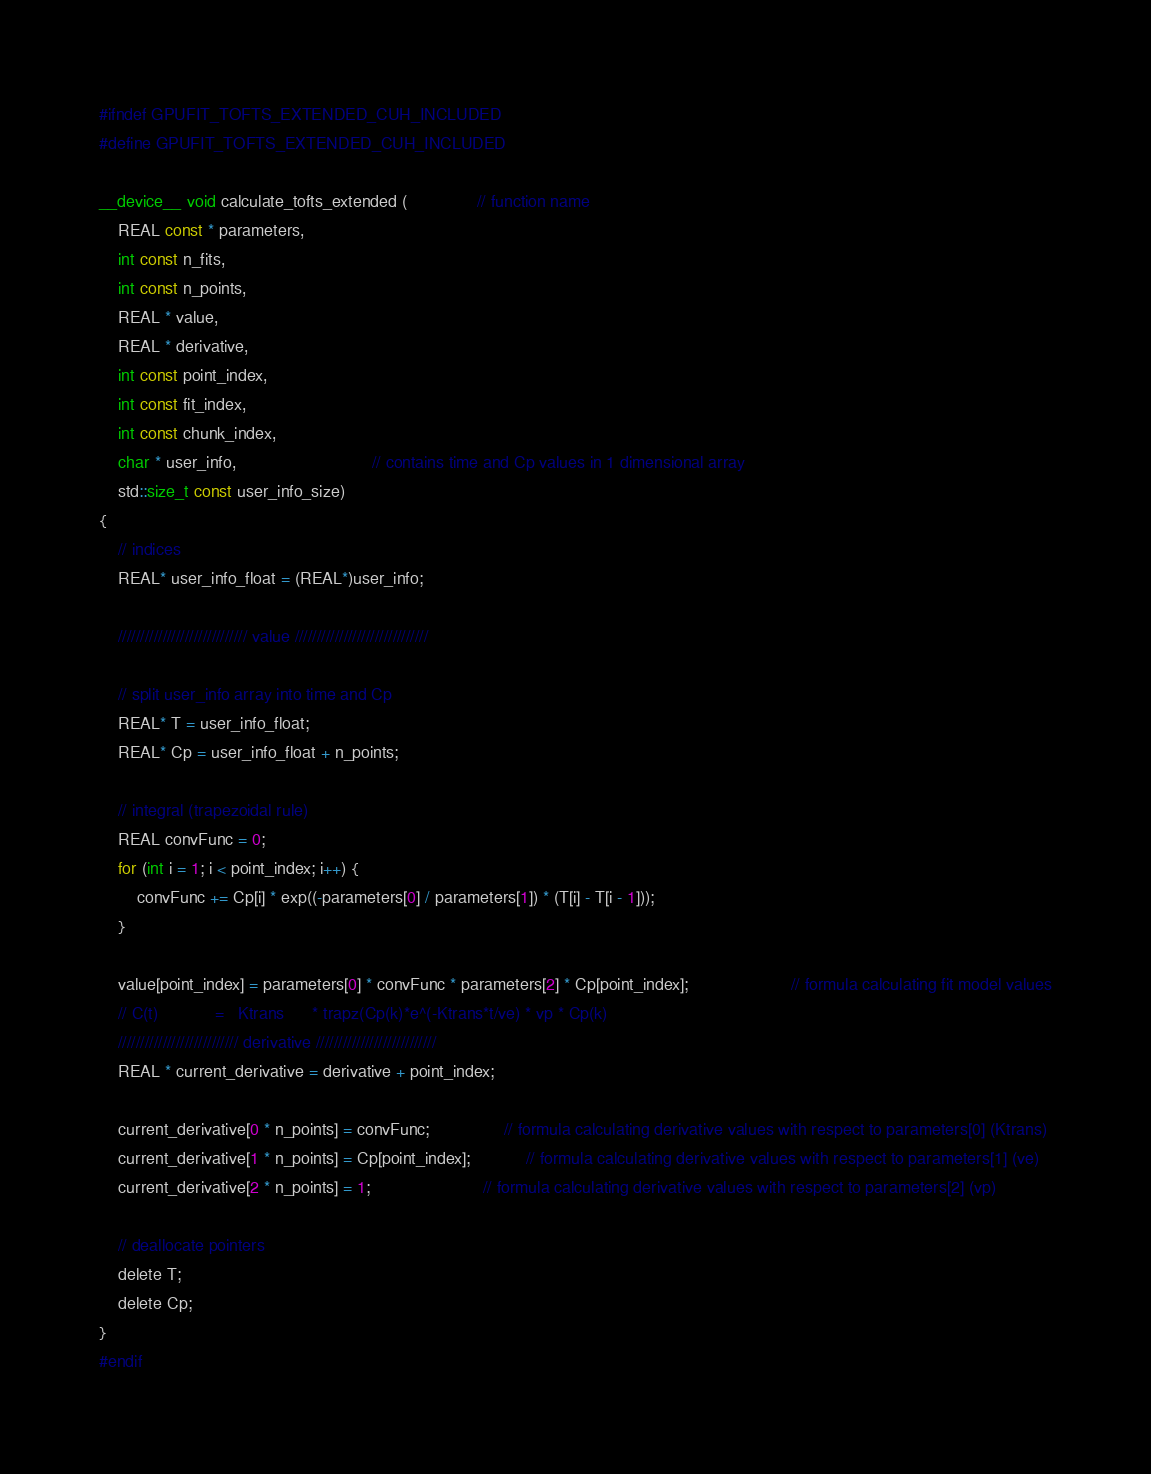Convert code to text. <code><loc_0><loc_0><loc_500><loc_500><_Cuda_>#ifndef GPUFIT_TOFTS_EXTENDED_CUH_INCLUDED
#define GPUFIT_TOFTS_EXTENDED_CUH_INCLUDED

__device__ void calculate_tofts_extended (               // function name
	REAL const * parameters,
	int const n_fits,
	int const n_points,
	REAL * value,
	REAL * derivative,
	int const point_index,						 
	int const fit_index,
	int const chunk_index,
	char * user_info,							 // contains time and Cp values in 1 dimensional array
	std::size_t const user_info_size)
{
	// indices
	REAL* user_info_float = (REAL*)user_info;

	///////////////////////////// value //////////////////////////////

	// split user_info array into time and Cp
	REAL* T = user_info_float;
	REAL* Cp = user_info_float + n_points;

	// integral (trapezoidal rule)
	REAL convFunc = 0;
	for (int i = 1; i < point_index; i++) {
		convFunc += Cp[i] * exp((-parameters[0] / parameters[1]) * (T[i] - T[i - 1]));
	}

	value[point_index] = parameters[0] * convFunc * parameters[2] * Cp[point_index];                      // formula calculating fit model values
	// C(t)		       =   Ktrans	   * trapz(Cp(k)*e^(-Ktrans*t/ve) * vp * Cp(k)
	/////////////////////////// derivative ///////////////////////////
	REAL * current_derivative = derivative + point_index;

	current_derivative[0 * n_points] = convFunc;				// formula calculating derivative values with respect to parameters[0] (Ktrans)
	current_derivative[1 * n_points] = Cp[point_index];			// formula calculating derivative values with respect to parameters[1] (ve)
	current_derivative[2 * n_points] = 1;						// formula calculating derivative values with respect to parameters[2] (vp)

	// deallocate pointers
	delete T;
	delete Cp;
}
#endif
</code> 